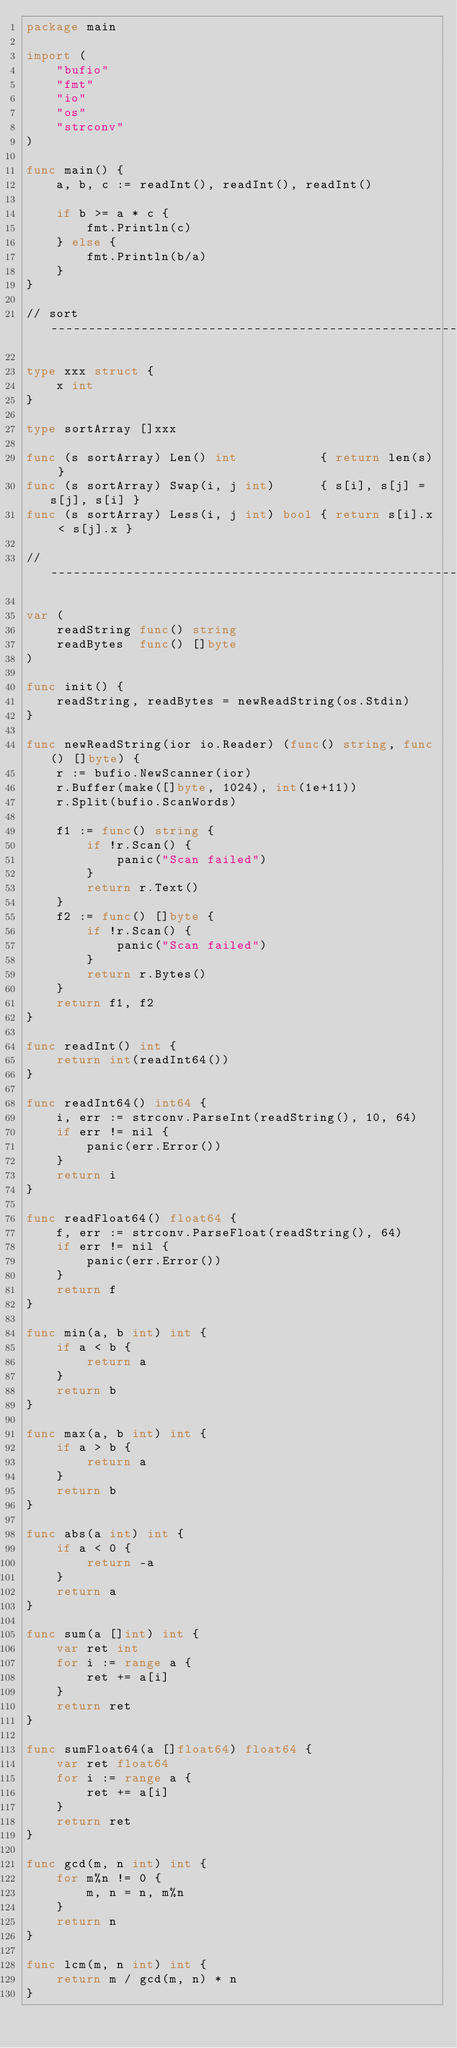Convert code to text. <code><loc_0><loc_0><loc_500><loc_500><_Go_>package main

import (
	"bufio"
	"fmt"
	"io"
	"os"
	"strconv"
)

func main() {
	a, b, c := readInt(), readInt(), readInt()

	if b >= a * c {
		fmt.Println(c)
	} else {
		fmt.Println(b/a)
	}
}

// sort ------------------------------------------------------------

type xxx struct {
	x int
}

type sortArray []xxx

func (s sortArray) Len() int           { return len(s) }
func (s sortArray) Swap(i, j int)      { s[i], s[j] = s[j], s[i] }
func (s sortArray) Less(i, j int) bool { return s[i].x < s[j].x }

// -----------------------------------------------------------------

var (
	readString func() string
	readBytes  func() []byte
)

func init() {
	readString, readBytes = newReadString(os.Stdin)
}

func newReadString(ior io.Reader) (func() string, func() []byte) {
	r := bufio.NewScanner(ior)
	r.Buffer(make([]byte, 1024), int(1e+11))
	r.Split(bufio.ScanWords)

	f1 := func() string {
		if !r.Scan() {
			panic("Scan failed")
		}
		return r.Text()
	}
	f2 := func() []byte {
		if !r.Scan() {
			panic("Scan failed")
		}
		return r.Bytes()
	}
	return f1, f2
}

func readInt() int {
	return int(readInt64())
}

func readInt64() int64 {
	i, err := strconv.ParseInt(readString(), 10, 64)
	if err != nil {
		panic(err.Error())
	}
	return i
}

func readFloat64() float64 {
	f, err := strconv.ParseFloat(readString(), 64)
	if err != nil {
		panic(err.Error())
	}
	return f
}

func min(a, b int) int {
	if a < b {
		return a
	}
	return b
}

func max(a, b int) int {
	if a > b {
		return a
	}
	return b
}

func abs(a int) int {
	if a < 0 {
		return -a
	}
	return a
}

func sum(a []int) int {
	var ret int
	for i := range a {
		ret += a[i]
	}
	return ret
}

func sumFloat64(a []float64) float64 {
	var ret float64
	for i := range a {
		ret += a[i]
	}
	return ret
}

func gcd(m, n int) int {
	for m%n != 0 {
		m, n = n, m%n
	}
	return n
}

func lcm(m, n int) int {
	return m / gcd(m, n) * n
}
</code> 